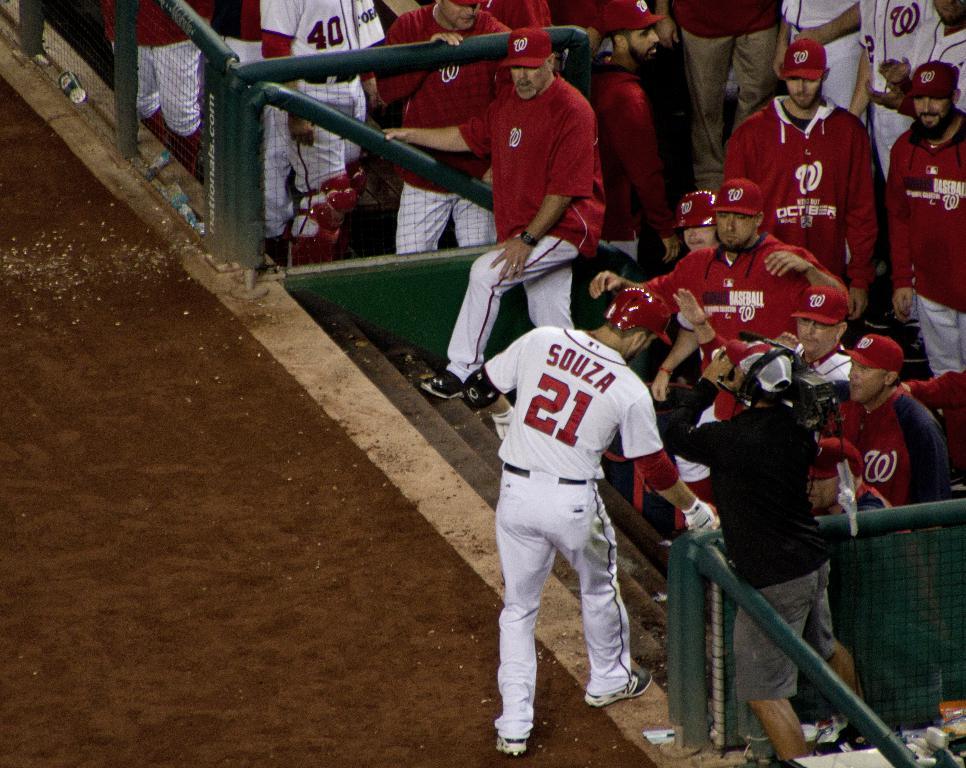What name does the player have on his jersey?
Keep it short and to the point. Souza. What number is on the player's back?
Your response must be concise. 21. 